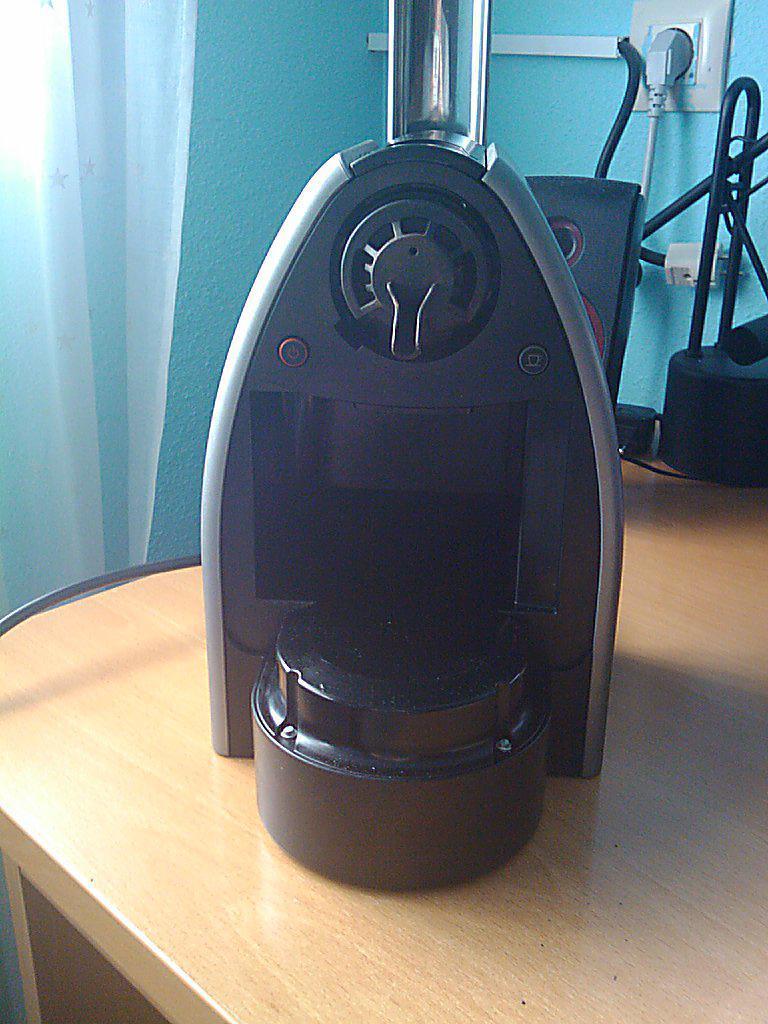In one or two sentences, can you explain what this image depicts? In the picture I can see a metal iron box on the wooden table. I can see a socket on the wall on the top right side of the picture. It is looking like a speaker on the table. There is a curtain on the top left side of the picture. 